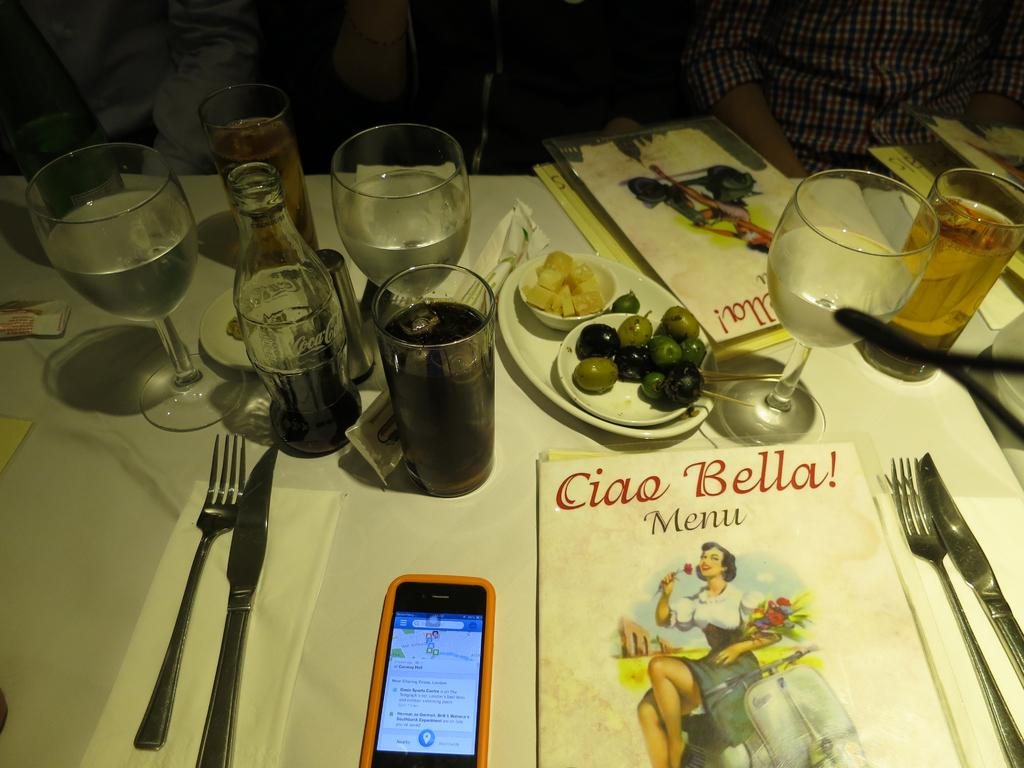What objects are present on the table in the image? There are bottles, glasses, a card, a fork, a knife, fruits, and a mobile on the table. What type of utensils can be seen on the table? There is a fork and a knife on the table. What is the purpose of the card on the table? The purpose of the card on the table is not clear from the image, but it could be a menu, a note, or a decorative item. What is the nature of the objects on the table? The objects on the table are a mix of food items (fruits), tableware (bottles, glasses, fork, knife), and a mobile. How many persons are present in the image? Two persons are sitting on chairs beside the table. What type of beam is holding up the table in the image? There is no beam present in the image; the table is supported by its legs. What type of whip is being used by the person sitting on the chair? There is no whip present in the image; the persons are sitting on chairs beside the table without any whips. 